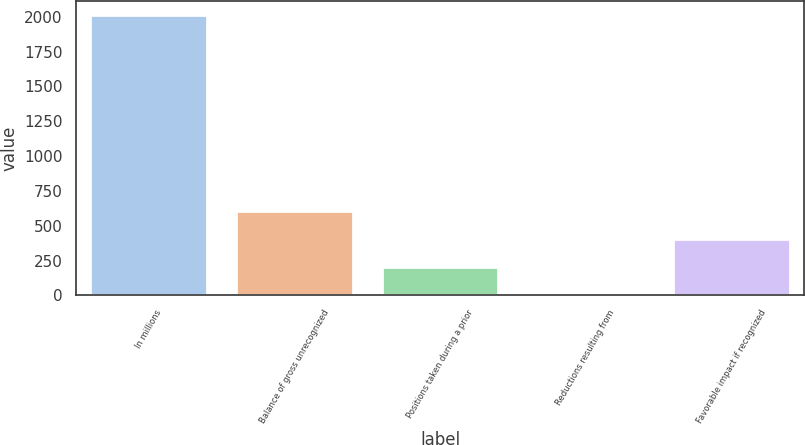Convert chart. <chart><loc_0><loc_0><loc_500><loc_500><bar_chart><fcel>In millions<fcel>Balance of gross unrecognized<fcel>Positions taken during a prior<fcel>Reductions resulting from<fcel>Favorable impact if recognized<nl><fcel>2014<fcel>607.7<fcel>205.9<fcel>5<fcel>406.8<nl></chart> 